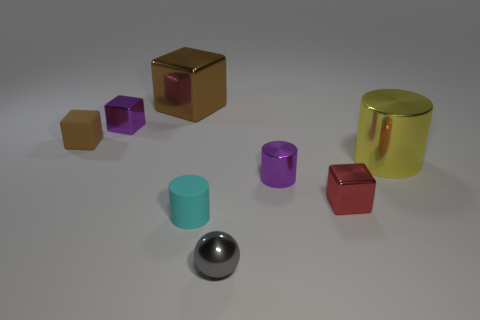What shape is the small purple object that is to the left of the small cyan rubber cylinder?
Your answer should be compact. Cube. Is there anything else that is the same shape as the small gray object?
Provide a short and direct response. No. Is there a gray ball?
Make the answer very short. Yes. There is a metallic block that is on the left side of the big brown cube; is it the same size as the cube that is to the right of the cyan matte thing?
Your response must be concise. Yes. What material is the cylinder that is behind the tiny cyan rubber cylinder and in front of the large cylinder?
Your response must be concise. Metal. There is a small rubber cube; what number of small rubber things are to the right of it?
Make the answer very short. 1. Is there any other thing that is the same size as the purple metallic cylinder?
Offer a very short reply. Yes. There is a small cylinder that is made of the same material as the large cylinder; what color is it?
Your answer should be very brief. Purple. Do the cyan rubber thing and the large yellow metallic thing have the same shape?
Offer a terse response. Yes. What number of metal things are both left of the red shiny block and in front of the small matte cube?
Provide a succinct answer. 2. 